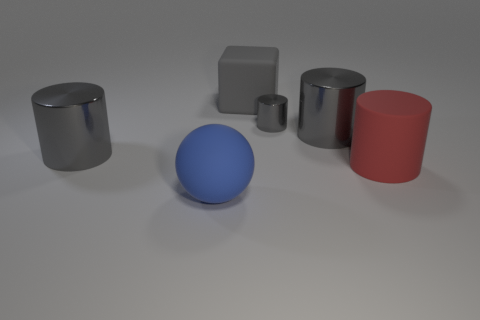Can you describe the arrangement of the shapes in order of size? Certainly! Beginning with the largest, there's the big red cylinder, followed by the large blue sphere. Next in size is the grey cylinder, and then the grey cuboid. Finally, the smallest object is the small red cylinder in the background. 